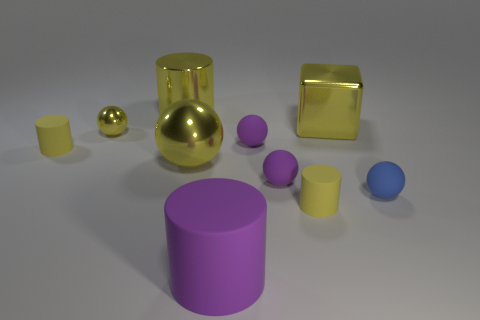Subtract all cyan cubes. How many yellow cylinders are left? 3 Subtract all gray balls. Subtract all brown cylinders. How many balls are left? 5 Subtract all cylinders. How many objects are left? 6 Add 6 small balls. How many small balls are left? 10 Add 6 big brown metallic cylinders. How many big brown metallic cylinders exist? 6 Subtract 1 purple spheres. How many objects are left? 9 Subtract all large rubber cylinders. Subtract all purple matte spheres. How many objects are left? 7 